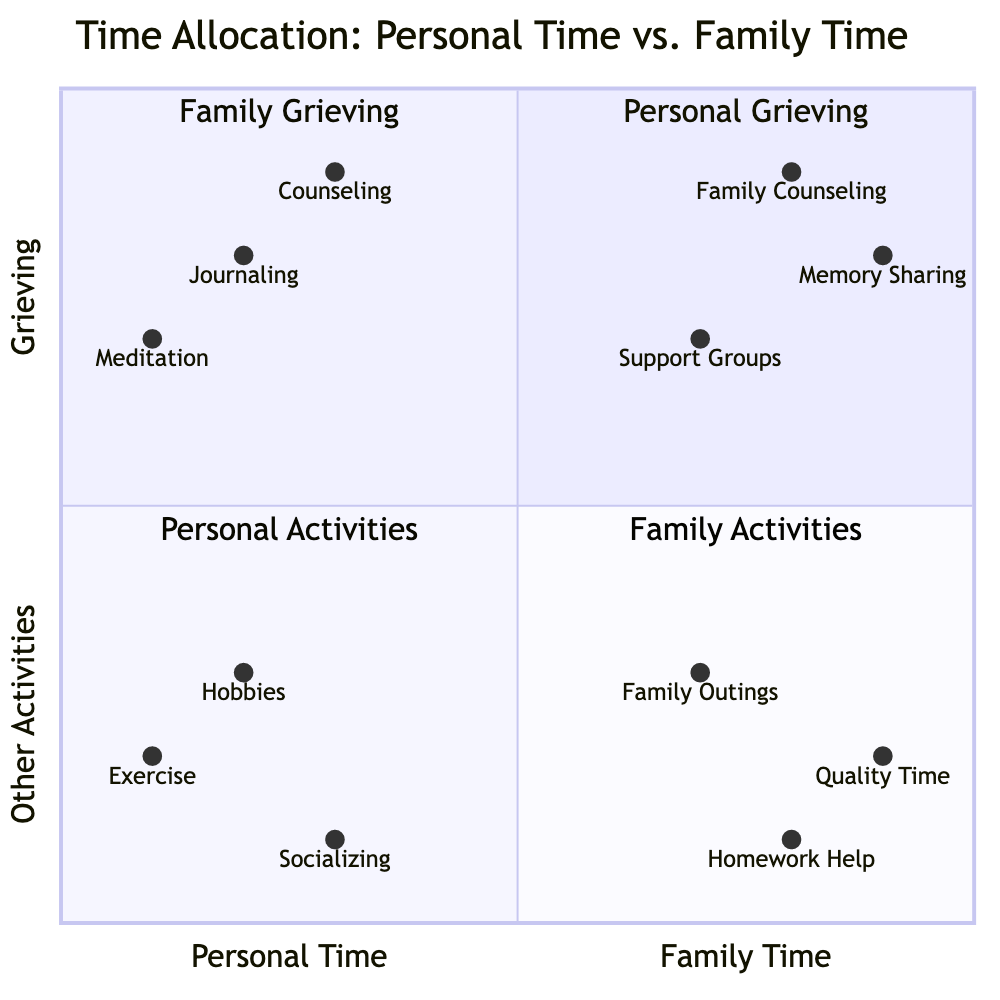What quadrant does journaling fall into? Journaling is located in the quadrant labeled "Personal Grieving," which is in the top left section of the diagram where personal time intersects with grieving.
Answer: Personal Grieving Which activity is closest to family time and grieving? "Family Counseling" is the activity that is closest to the intersection of family time and grieving, situated high in the quadrant where those two categories meet.
Answer: Family Counseling How many activities are listed under "Family Activities"? There are three activities: Quality Time, Homework Help, and Family Outings, which are all located in the bottom right quadrant labeled "Family Activities."
Answer: 3 Which activity has the lowest value associated with grieving? "Exercise" has the lowest value associated with grieving, positioned at [0.1, 0.2] in the quadrant, indicating minimal allocation towards grieving activities.
Answer: Exercise What is the relationship between memory sharing and family time? Memory Sharing is associated with family time in the top right quadrant, indicating that this activity involves family engagement while coping with grief.
Answer: Family Time Which personal activity is the farthest from family time? "Socializing" is the farthest from family time, located at [0.3, 0.1], showing that it's much more aligned with personal time and less focused on family interactions.
Answer: Socializing How does the total number of activities in "Personal Time" compare to "Family Time"? There are six activities listed under Personal Time (3 under Grieving and 3 under Other Activities) and also six activities under Family Time (3 under Grieving and 3 under Other Activities), showing an equal total for both categories.
Answer: Equal Which grieving activity has the highest family time interaction? "Support Groups" is the activity that shows a high family time interaction, located closer to the center in the quadrant of Family Grieving.
Answer: Support Groups What is the overall theme of the top left quadrant? The top left quadrant is themed around "Personal Grieving," focusing on activities that individuals can engage in alone for coping with loss.
Answer: Personal Grieving 